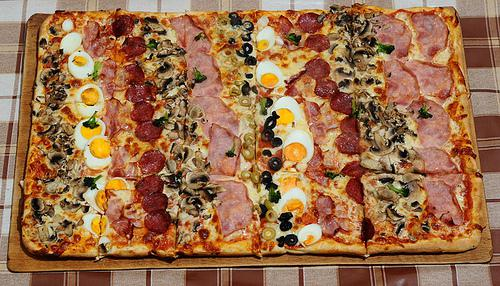Question: what shape is the pizza?
Choices:
A. Rectangle.
B. Round.
C. Triangle slices.
D. Square.
Answer with the letter. Answer: A Question: how many slices of pizza are there?
Choices:
A. 6.
B. 7.
C. 20.
D. 8.
Answer with the letter. Answer: C Question: what colors are the tablecloth?
Choices:
A. White.
B. Blue.
C. Green.
D. Red and white.
Answer with the letter. Answer: D Question: what is the round meat topping?
Choices:
A. Sausage.
B. Canandian Bacon.
C. Pepperoni.
D. Ham.
Answer with the letter. Answer: C Question: what are the yellow circles?
Choices:
A. A dodge ball court.
B. Decorations.
C. Spilled paint.
D. Egg yolk.
Answer with the letter. Answer: D 